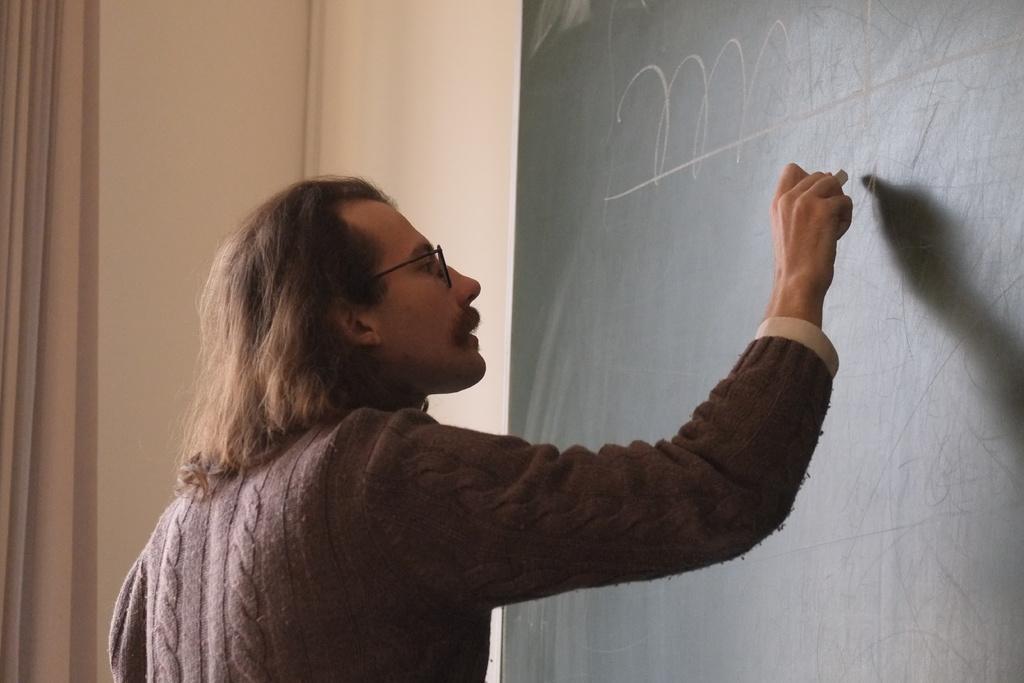Please provide a concise description of this image. In this image we can see a person holding a choke and writing on the board, which is attached to the wall. 